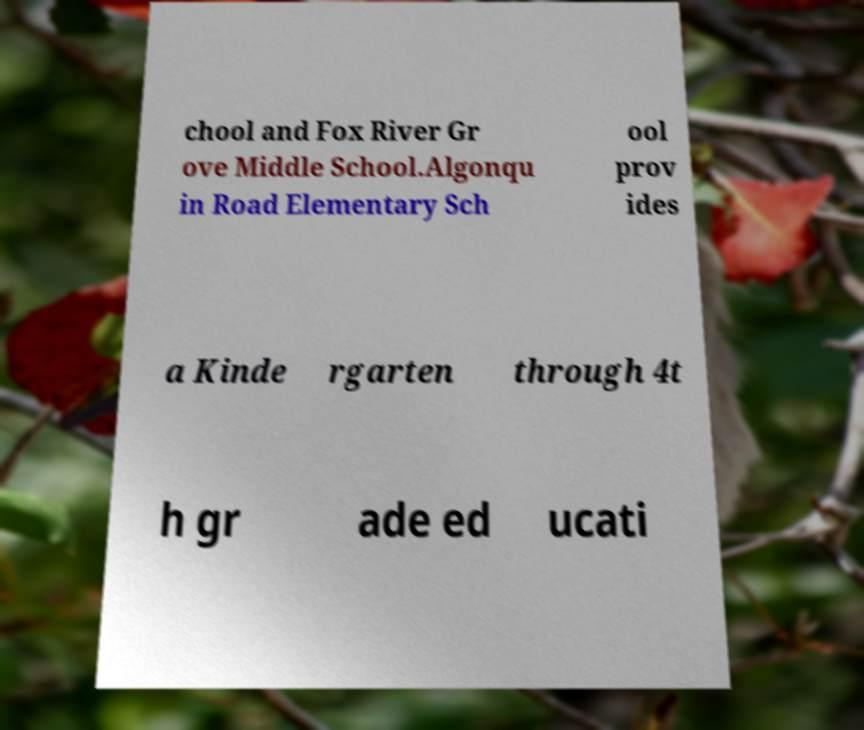Could you assist in decoding the text presented in this image and type it out clearly? chool and Fox River Gr ove Middle School.Algonqu in Road Elementary Sch ool prov ides a Kinde rgarten through 4t h gr ade ed ucati 